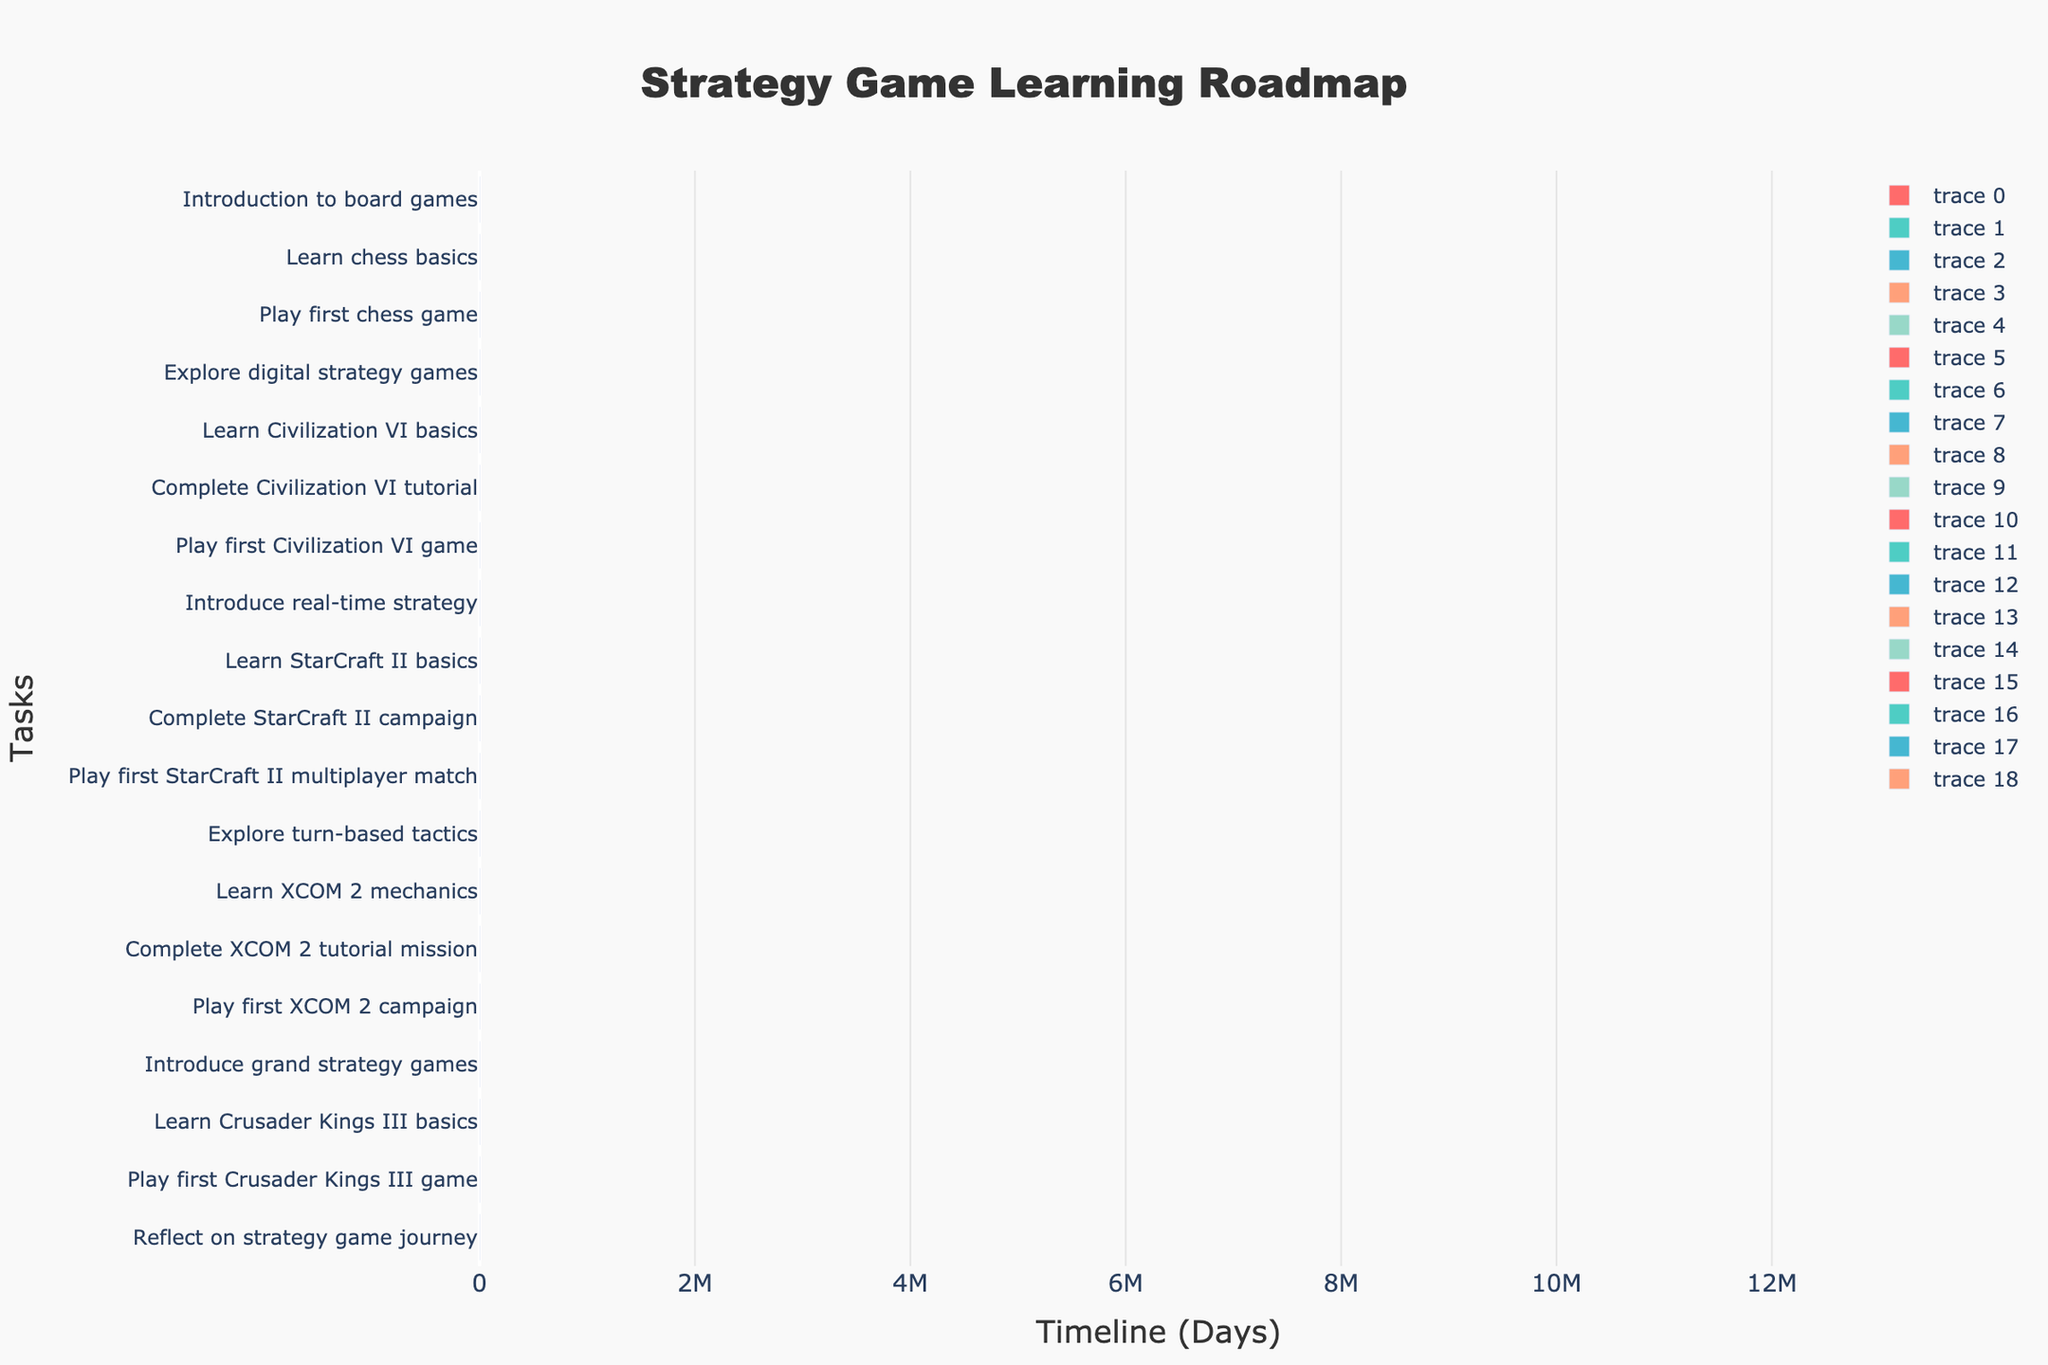How long does it take to learn Civilization VI basics? By examining the duration bar for the task "Learn Civilization VI basics", we see its length spans 10 days.
Answer: 10 days On which day does the roadmap suggest starting real-time strategy games? The "Introduce real-time strategy" task starts on day 45 as indicated by the beginning of the respective bar.
Answer: Day 45 Which task takes the longest duration to complete? By comparing the lengths of all task bars, "Complete StarCraft II campaign" is the longest with a duration of 14 days.
Answer: Complete StarCraft II campaign Which task follows the completion of the XCOM 2 tutorial mission? By identifying the next bar post "Complete XCOM 2 tutorial mission", the "Play first XCOM 2 campaign" follows.
Answer: Play first XCOM 2 campaign What time frame is covered by the StarCraft II basics? Observing the "Learn StarCraft II basics" bar shows it starts on day 50 and lasts 10 days, ending on day 60.
Answer: Day 50 to Day 60 Which game introduction starts first and lasts the longest? Comparing the task starts and durations, "Learn chess basics" begins the earliest (on day 8) and lasts the longest (14 days) compared to other introductory tasks.
Answer: Learn chess basics How many days after starting do you play your first digital strategy game (Civilization VI)? Looking at the start day of "Play first Civilization VI game" (day 43) and subtracting the start day of "Explore digital strategy games" (day 23) yields a 20-day gap.
Answer: 20 days When does the reflection on the strategy game journey commence in the roadmap? The task "Reflect on strategy game journey" starts on day 132, as indicated by its placement in the Gantt chart.
Answer: Day 132 What is the cumulative duration for all tasks related to XCOM 2? Summing the durations of "Learn XCOM 2 mechanics" (10 days), "Complete XCOM 2 tutorial mission" (2 days), and "Play first XCOM 2 campaign" (14 days) totals 26 days.
Answer: 26 days How many months does the entire roadmap span? The roadmap starts on day 1 and ends on day 134, translating approximately into 4.5 months.
Answer: About 4.5 months 